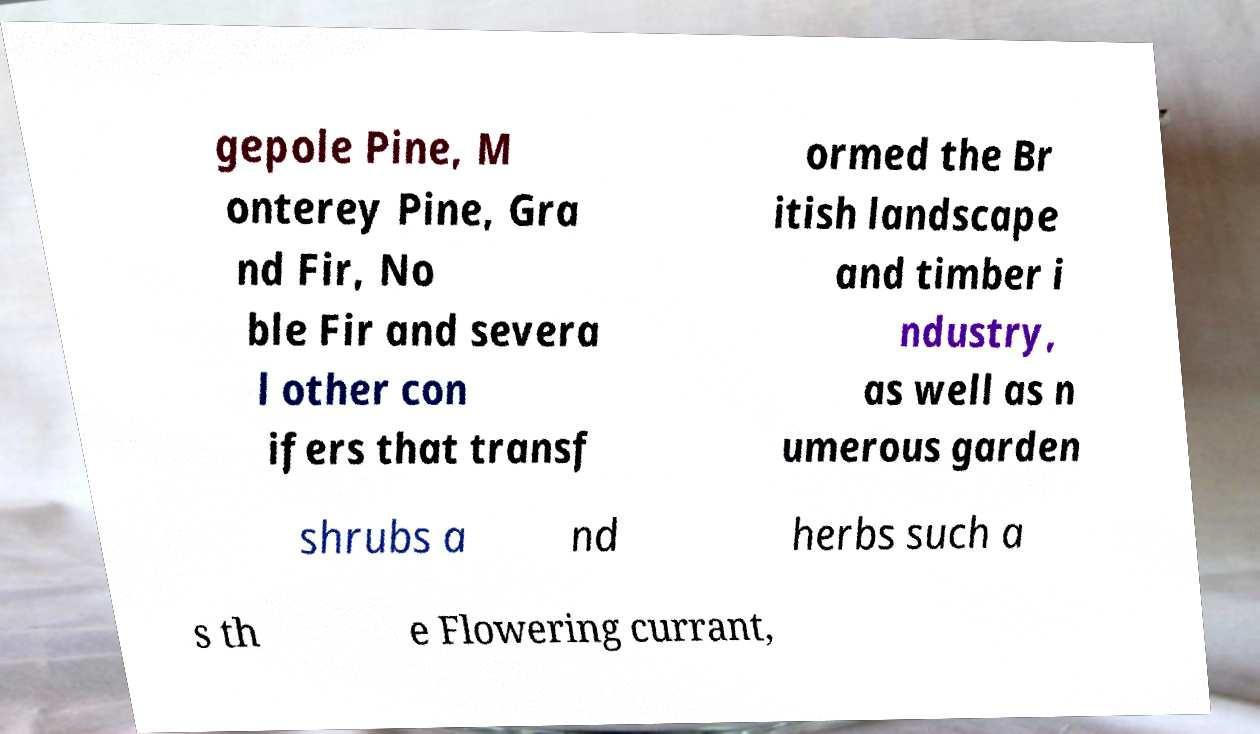Please identify and transcribe the text found in this image. gepole Pine, M onterey Pine, Gra nd Fir, No ble Fir and severa l other con ifers that transf ormed the Br itish landscape and timber i ndustry, as well as n umerous garden shrubs a nd herbs such a s th e Flowering currant, 